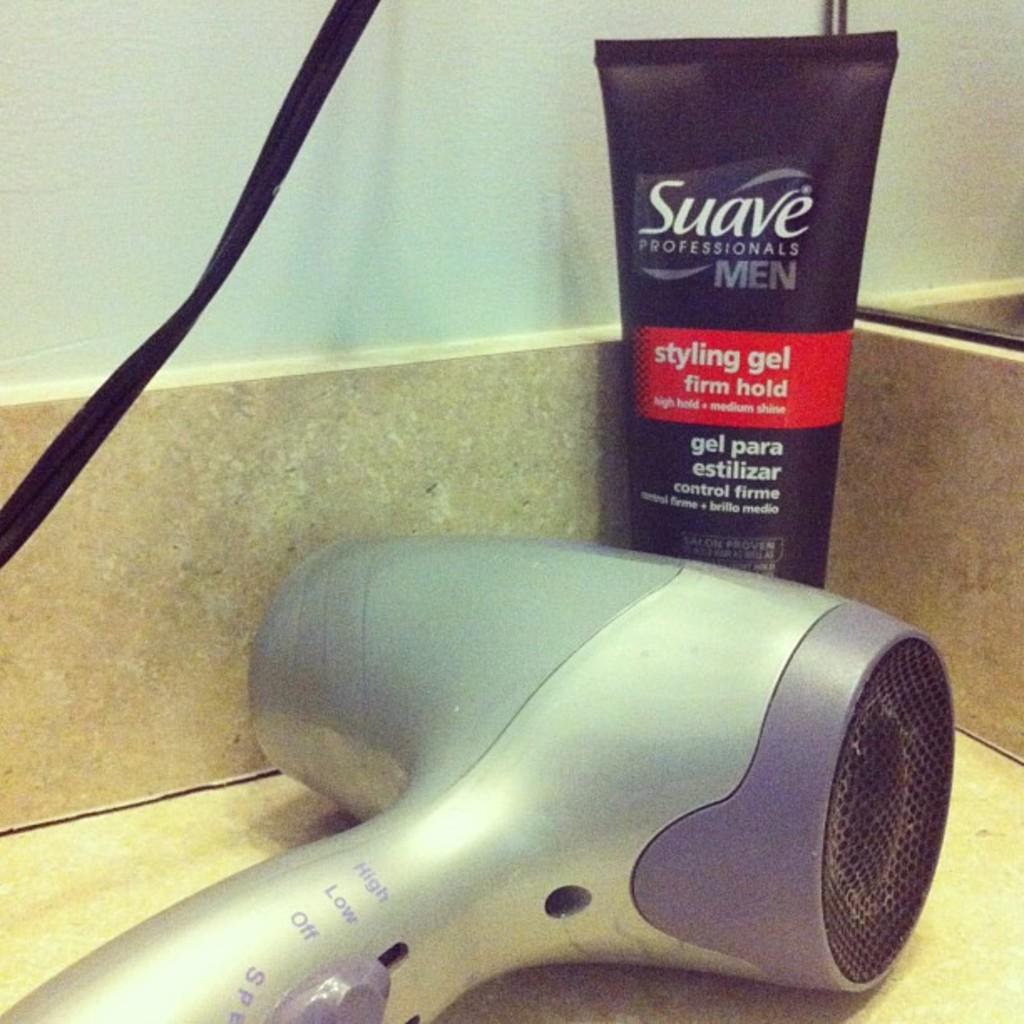How would you summarize this image in a sentence or two? This image consists of a hair dryer along with a gel tube are kept on the desk. In the background, there is a wall in white color. 